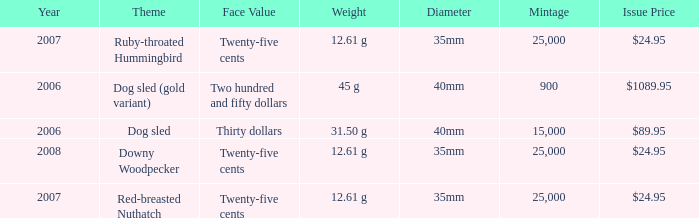Parse the full table. {'header': ['Year', 'Theme', 'Face Value', 'Weight', 'Diameter', 'Mintage', 'Issue Price'], 'rows': [['2007', 'Ruby-throated Hummingbird', 'Twenty-five cents', '12.61 g', '35mm', '25,000', '$24.95'], ['2006', 'Dog sled (gold variant)', 'Two hundred and fifty dollars', '45 g', '40mm', '900', '$1089.95'], ['2006', 'Dog sled', 'Thirty dollars', '31.50 g', '40mm', '15,000', '$89.95'], ['2008', 'Downy Woodpecker', 'Twenty-five cents', '12.61 g', '35mm', '25,000', '$24.95'], ['2007', 'Red-breasted Nuthatch', 'Twenty-five cents', '12.61 g', '35mm', '25,000', '$24.95']]} What is the Year of the Coin with an Issue Price of $1089.95 and Mintage less than 900? None. 